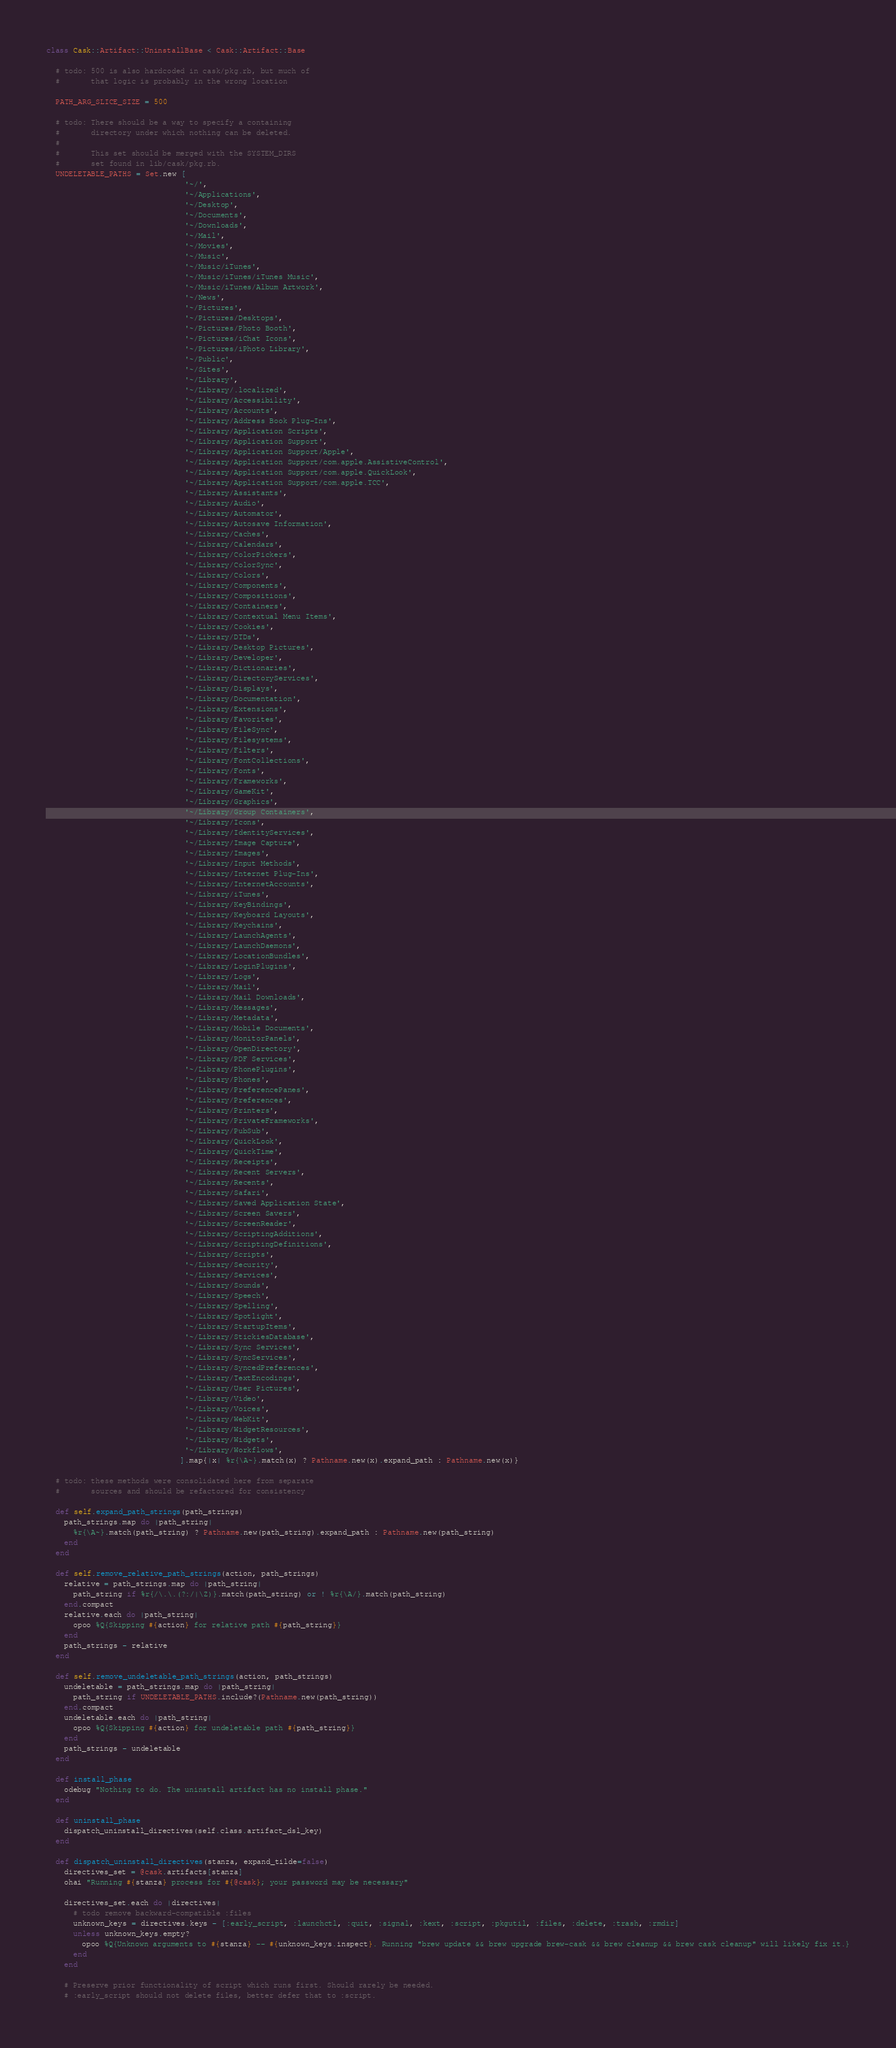<code> <loc_0><loc_0><loc_500><loc_500><_Ruby_>class Cask::Artifact::UninstallBase < Cask::Artifact::Base

  # todo: 500 is also hardcoded in cask/pkg.rb, but much of
  #       that logic is probably in the wrong location

  PATH_ARG_SLICE_SIZE = 500

  # todo: There should be a way to specify a containing
  #       directory under which nothing can be deleted.
  #
  #       This set should be merged with the SYSTEM_DIRS
  #       set found in lib/cask/pkg.rb.
  UNDELETABLE_PATHS = Set.new [
                               '~/',
                               '~/Applications',
                               '~/Desktop',
                               '~/Documents',
                               '~/Downloads',
                               '~/Mail',
                               '~/Movies',
                               '~/Music',
                               '~/Music/iTunes',
                               '~/Music/iTunes/iTunes Music',
                               '~/Music/iTunes/Album Artwork',
                               '~/News',
                               '~/Pictures',
                               '~/Pictures/Desktops',
                               '~/Pictures/Photo Booth',
                               '~/Pictures/iChat Icons',
                               '~/Pictures/iPhoto Library',
                               '~/Public',
                               '~/Sites',
                               '~/Library',
                               '~/Library/.localized',
                               '~/Library/Accessibility',
                               '~/Library/Accounts',
                               '~/Library/Address Book Plug-Ins',
                               '~/Library/Application Scripts',
                               '~/Library/Application Support',
                               '~/Library/Application Support/Apple',
                               '~/Library/Application Support/com.apple.AssistiveControl',
                               '~/Library/Application Support/com.apple.QuickLook',
                               '~/Library/Application Support/com.apple.TCC',
                               '~/Library/Assistants',
                               '~/Library/Audio',
                               '~/Library/Automator',
                               '~/Library/Autosave Information',
                               '~/Library/Caches',
                               '~/Library/Calendars',
                               '~/Library/ColorPickers',
                               '~/Library/ColorSync',
                               '~/Library/Colors',
                               '~/Library/Components',
                               '~/Library/Compositions',
                               '~/Library/Containers',
                               '~/Library/Contextual Menu Items',
                               '~/Library/Cookies',
                               '~/Library/DTDs',
                               '~/Library/Desktop Pictures',
                               '~/Library/Developer',
                               '~/Library/Dictionaries',
                               '~/Library/DirectoryServices',
                               '~/Library/Displays',
                               '~/Library/Documentation',
                               '~/Library/Extensions',
                               '~/Library/Favorites',
                               '~/Library/FileSync',
                               '~/Library/Filesystems',
                               '~/Library/Filters',
                               '~/Library/FontCollections',
                               '~/Library/Fonts',
                               '~/Library/Frameworks',
                               '~/Library/GameKit',
                               '~/Library/Graphics',
                               '~/Library/Group Containers',
                               '~/Library/Icons',
                               '~/Library/IdentityServices',
                               '~/Library/Image Capture',
                               '~/Library/Images',
                               '~/Library/Input Methods',
                               '~/Library/Internet Plug-Ins',
                               '~/Library/InternetAccounts',
                               '~/Library/iTunes',
                               '~/Library/KeyBindings',
                               '~/Library/Keyboard Layouts',
                               '~/Library/Keychains',
                               '~/Library/LaunchAgents',
                               '~/Library/LaunchDaemons',
                               '~/Library/LocationBundles',
                               '~/Library/LoginPlugins',
                               '~/Library/Logs',
                               '~/Library/Mail',
                               '~/Library/Mail Downloads',
                               '~/Library/Messages',
                               '~/Library/Metadata',
                               '~/Library/Mobile Documents',
                               '~/Library/MonitorPanels',
                               '~/Library/OpenDirectory',
                               '~/Library/PDF Services',
                               '~/Library/PhonePlugins',
                               '~/Library/Phones',
                               '~/Library/PreferencePanes',
                               '~/Library/Preferences',
                               '~/Library/Printers',
                               '~/Library/PrivateFrameworks',
                               '~/Library/PubSub',
                               '~/Library/QuickLook',
                               '~/Library/QuickTime',
                               '~/Library/Receipts',
                               '~/Library/Recent Servers',
                               '~/Library/Recents',
                               '~/Library/Safari',
                               '~/Library/Saved Application State',
                               '~/Library/Screen Savers',
                               '~/Library/ScreenReader',
                               '~/Library/ScriptingAdditions',
                               '~/Library/ScriptingDefinitions',
                               '~/Library/Scripts',
                               '~/Library/Security',
                               '~/Library/Services',
                               '~/Library/Sounds',
                               '~/Library/Speech',
                               '~/Library/Spelling',
                               '~/Library/Spotlight',
                               '~/Library/StartupItems',
                               '~/Library/StickiesDatabase',
                               '~/Library/Sync Services',
                               '~/Library/SyncServices',
                               '~/Library/SyncedPreferences',
                               '~/Library/TextEncodings',
                               '~/Library/User Pictures',
                               '~/Library/Video',
                               '~/Library/Voices',
                               '~/Library/WebKit',
                               '~/Library/WidgetResources',
                               '~/Library/Widgets',
                               '~/Library/Workflows',
                              ].map{|x| %r{\A~}.match(x) ? Pathname.new(x).expand_path : Pathname.new(x)}

  # todo: these methods were consolidated here from separate
  #       sources and should be refactored for consistency

  def self.expand_path_strings(path_strings)
    path_strings.map do |path_string|
      %r{\A~}.match(path_string) ? Pathname.new(path_string).expand_path : Pathname.new(path_string)
    end
  end

  def self.remove_relative_path_strings(action, path_strings)
    relative = path_strings.map do |path_string|
      path_string if %r{/\.\.(?:/|\Z)}.match(path_string) or ! %r{\A/}.match(path_string)
    end.compact
    relative.each do |path_string|
      opoo %Q{Skipping #{action} for relative path #{path_string}}
    end
    path_strings - relative
  end

  def self.remove_undeletable_path_strings(action, path_strings)
    undeletable = path_strings.map do |path_string|
      path_string if UNDELETABLE_PATHS.include?(Pathname.new(path_string))
    end.compact
    undeletable.each do |path_string|
      opoo %Q{Skipping #{action} for undeletable path #{path_string}}
    end
    path_strings - undeletable
  end

  def install_phase
    odebug "Nothing to do. The uninstall artifact has no install phase."
  end

  def uninstall_phase
    dispatch_uninstall_directives(self.class.artifact_dsl_key)
  end

  def dispatch_uninstall_directives(stanza, expand_tilde=false)
    directives_set = @cask.artifacts[stanza]
    ohai "Running #{stanza} process for #{@cask}; your password may be necessary"

    directives_set.each do |directives|
      # todo remove backward-compatible :files
      unknown_keys = directives.keys - [:early_script, :launchctl, :quit, :signal, :kext, :script, :pkgutil, :files, :delete, :trash, :rmdir]
      unless unknown_keys.empty?
        opoo %Q{Unknown arguments to #{stanza} -- #{unknown_keys.inspect}. Running "brew update && brew upgrade brew-cask && brew cleanup && brew cask cleanup" will likely fix it.}
      end
    end

    # Preserve prior functionality of script which runs first. Should rarely be needed.
    # :early_script should not delete files, better defer that to :script.</code> 